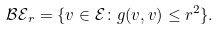<formula> <loc_0><loc_0><loc_500><loc_500>\mathcal { B E } _ { r } = \{ v \in \mathcal { E } \colon g ( v , v ) \leq r ^ { 2 } \} .</formula> 